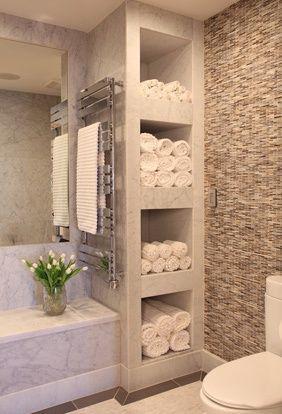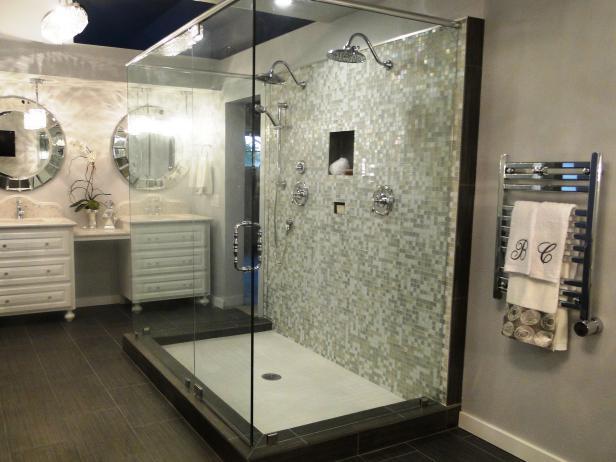The first image is the image on the left, the second image is the image on the right. Given the left and right images, does the statement "In at least one image there is an open drawer holding towels." hold true? Answer yes or no. No. The first image is the image on the left, the second image is the image on the right. Evaluate the accuracy of this statement regarding the images: "The left image shows a pull-out drawer containing towels, with a long horizontal handle on the drawer.". Is it true? Answer yes or no. No. 